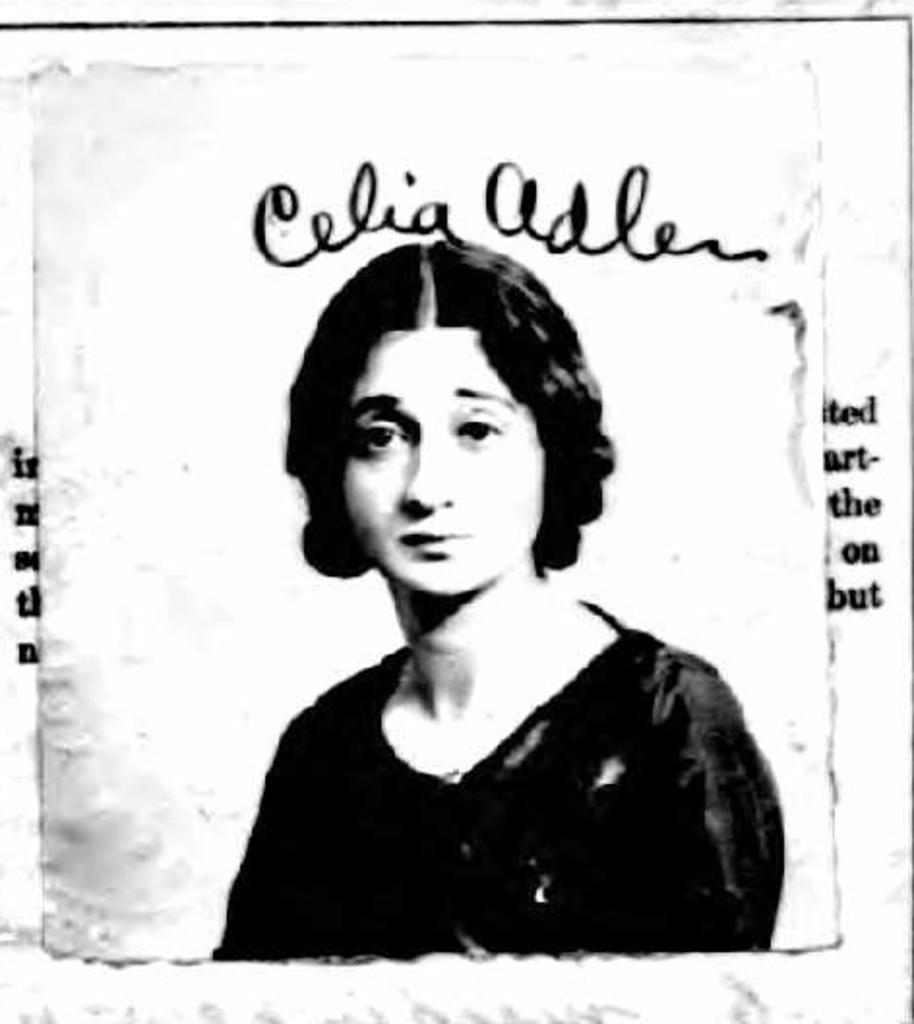What is the main subject of the image? There is a photograph of a woman in the image. What else can be seen in the image besides the photograph? There is text at the top, right side, and left side of the image. What type of tin can be seen in the image? There is no tin present in the image. How does the woman in the image participate in the war? The image does not depict any war or conflict, and there is no indication of the woman's involvement in such events. 